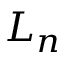<formula> <loc_0><loc_0><loc_500><loc_500>L _ { n }</formula> 